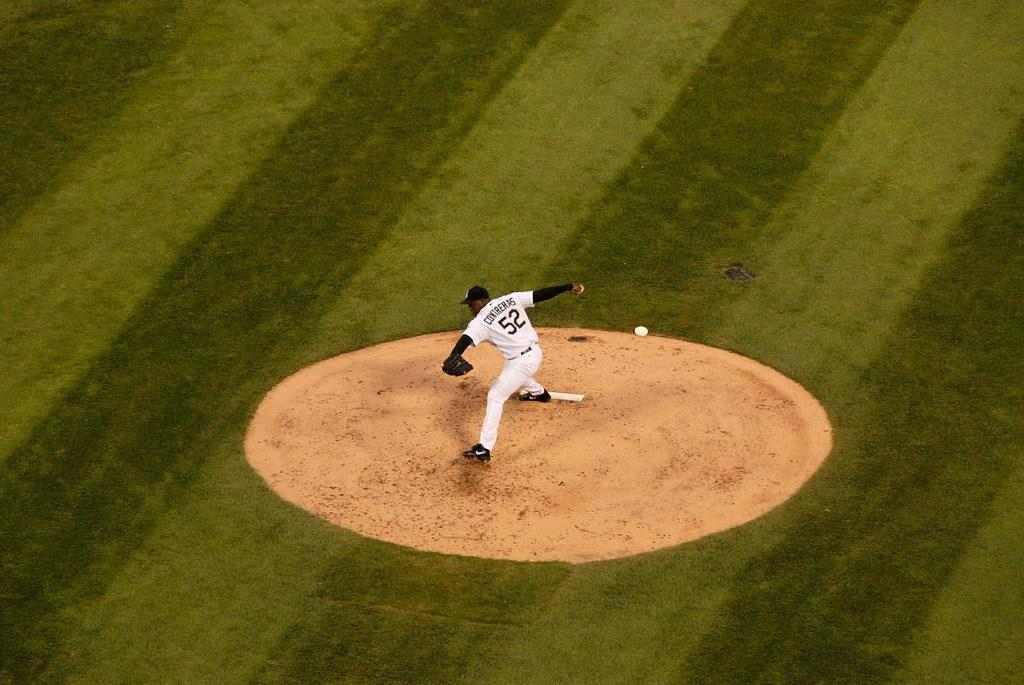<image>
Render a clear and concise summary of the photo. a pitcher that has the number 52 on their jersey 